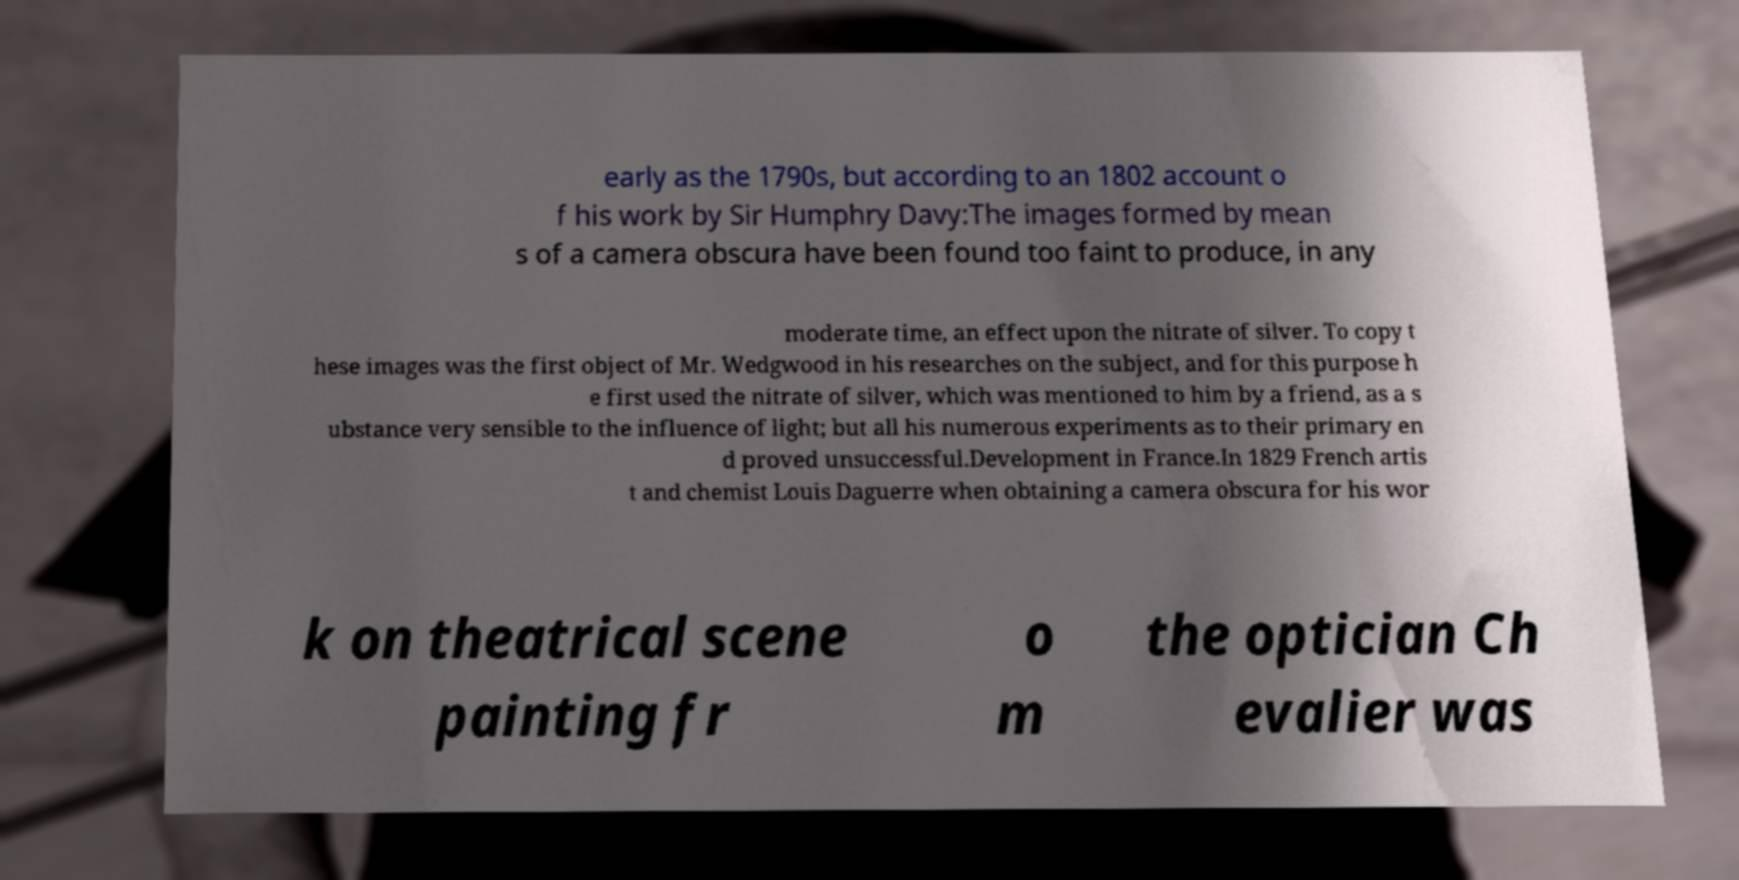Could you assist in decoding the text presented in this image and type it out clearly? early as the 1790s, but according to an 1802 account o f his work by Sir Humphry Davy:The images formed by mean s of a camera obscura have been found too faint to produce, in any moderate time, an effect upon the nitrate of silver. To copy t hese images was the first object of Mr. Wedgwood in his researches on the subject, and for this purpose h e first used the nitrate of silver, which was mentioned to him by a friend, as a s ubstance very sensible to the influence of light; but all his numerous experiments as to their primary en d proved unsuccessful.Development in France.In 1829 French artis t and chemist Louis Daguerre when obtaining a camera obscura for his wor k on theatrical scene painting fr o m the optician Ch evalier was 